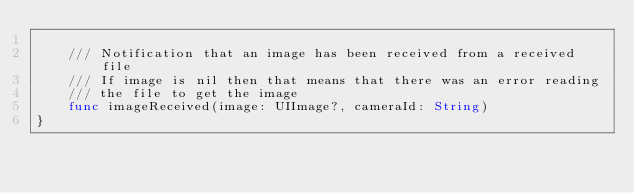Convert code to text. <code><loc_0><loc_0><loc_500><loc_500><_Swift_>
    /// Notification that an image has been received from a received file
    /// If image is nil then that means that there was an error reading
    /// the file to get the image
    func imageReceived(image: UIImage?, cameraId: String)
}
</code> 